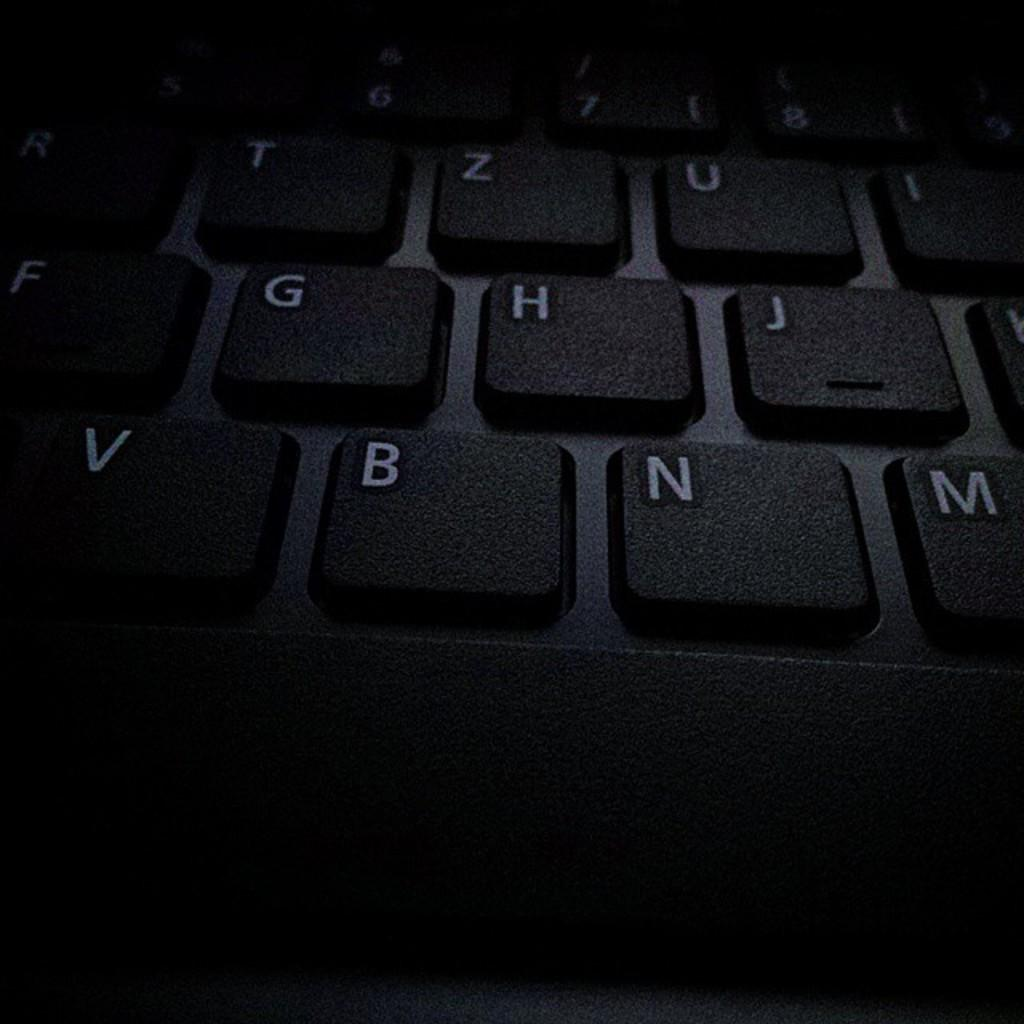<image>
Render a clear and concise summary of the photo. Computer keys are shown on a keyboard, including the letters B and G. 